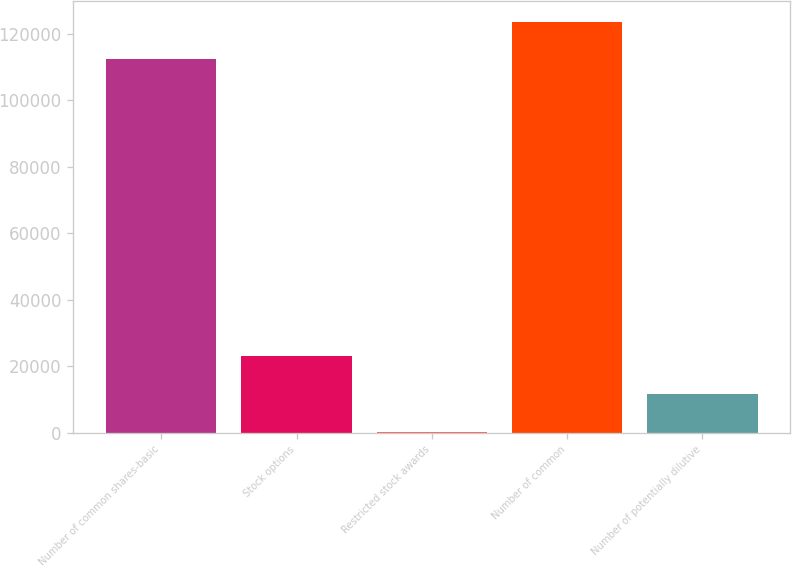Convert chart to OTSL. <chart><loc_0><loc_0><loc_500><loc_500><bar_chart><fcel>Number of common shares-basic<fcel>Stock options<fcel>Restricted stock awards<fcel>Number of common<fcel>Number of potentially dilutive<nl><fcel>112254<fcel>22914.2<fcel>267<fcel>123578<fcel>11590.6<nl></chart> 